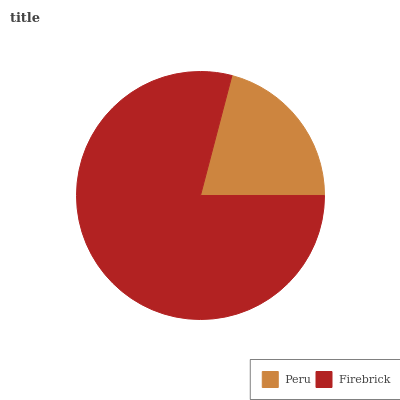Is Peru the minimum?
Answer yes or no. Yes. Is Firebrick the maximum?
Answer yes or no. Yes. Is Firebrick the minimum?
Answer yes or no. No. Is Firebrick greater than Peru?
Answer yes or no. Yes. Is Peru less than Firebrick?
Answer yes or no. Yes. Is Peru greater than Firebrick?
Answer yes or no. No. Is Firebrick less than Peru?
Answer yes or no. No. Is Firebrick the high median?
Answer yes or no. Yes. Is Peru the low median?
Answer yes or no. Yes. Is Peru the high median?
Answer yes or no. No. Is Firebrick the low median?
Answer yes or no. No. 